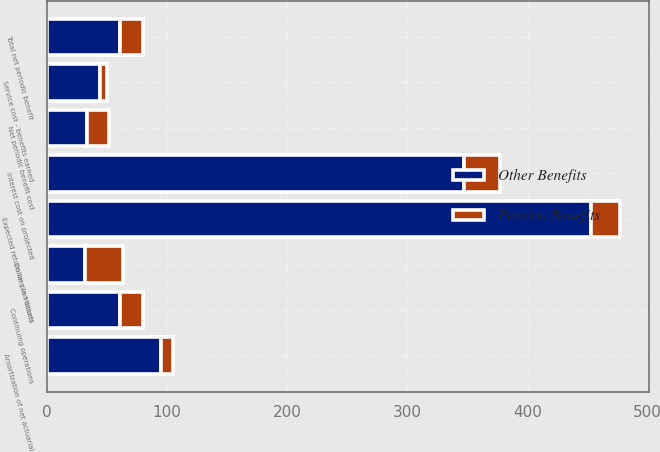<chart> <loc_0><loc_0><loc_500><loc_500><stacked_bar_chart><ecel><fcel>Dollars in Millions<fcel>Service cost - benefits earned<fcel>Interest cost on projected<fcel>Expected return on plan assets<fcel>Amortization of net actuarial<fcel>Net periodic benefit cost<fcel>Total net periodic benefit<fcel>Continuing operations<nl><fcel>Other Benefits<fcel>31.5<fcel>44<fcel>347<fcel>453<fcel>95<fcel>33<fcel>61<fcel>61<nl><fcel>Pension Benefits<fcel>31.5<fcel>6<fcel>30<fcel>24<fcel>10<fcel>19<fcel>19<fcel>19<nl></chart> 